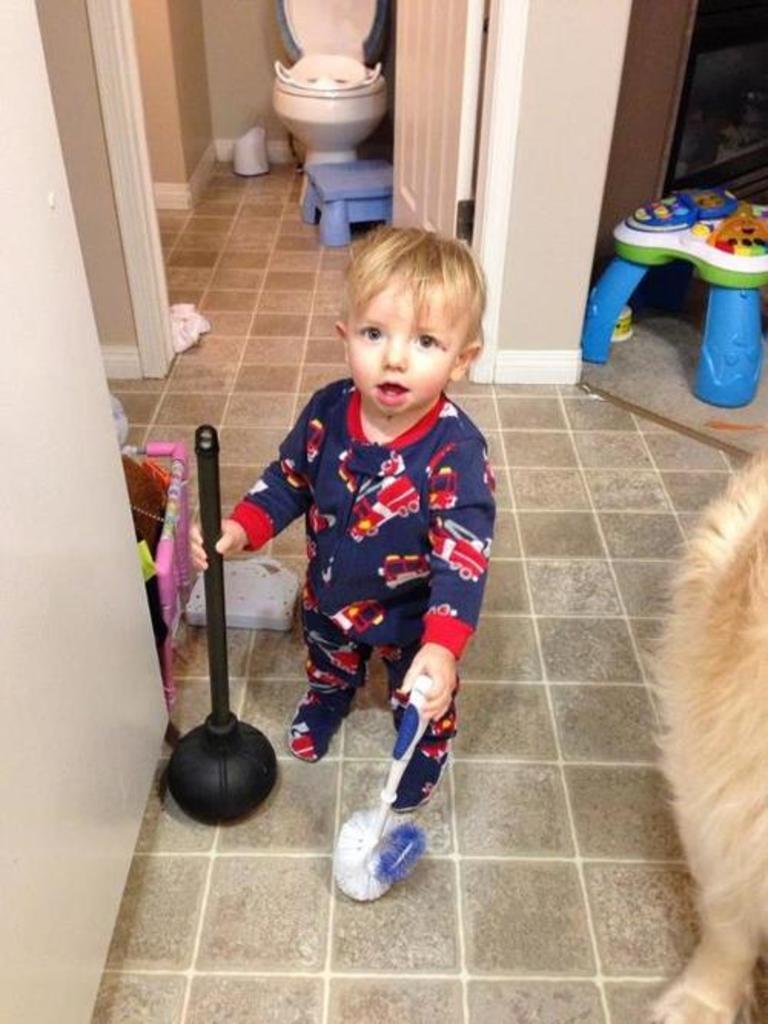Could you give a brief overview of what you see in this image? In this picture we can see a child is standing on the ground, holding a brush and an object, here we can see a dog, toilet seat, wall, door, stools and some objects. 